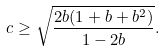<formula> <loc_0><loc_0><loc_500><loc_500>c \geq \sqrt { \frac { 2 b ( 1 + b + b ^ { 2 } ) } { 1 - 2 b } } .</formula> 